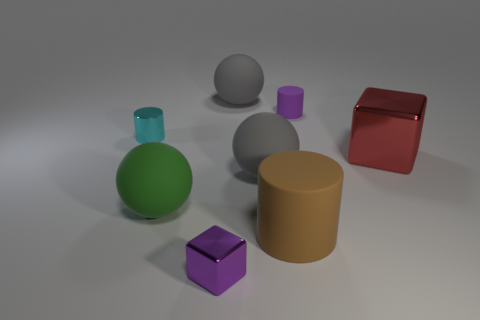Are there any metal objects right of the purple cube?
Provide a short and direct response. Yes. Are there any tiny rubber cylinders left of the cube that is in front of the large brown thing?
Offer a very short reply. No. Is the number of cyan cylinders in front of the brown matte thing the same as the number of gray matte spheres behind the small purple metallic block?
Offer a terse response. No. There is a small thing that is made of the same material as the green ball; what color is it?
Keep it short and to the point. Purple. Is there another cylinder made of the same material as the brown cylinder?
Make the answer very short. Yes. What number of objects are either big green things or large blue objects?
Make the answer very short. 1. Are the big brown object and the purple object that is in front of the small purple rubber cylinder made of the same material?
Provide a short and direct response. No. What is the size of the purple shiny object that is in front of the tiny purple matte cylinder?
Offer a terse response. Small. Are there fewer brown matte cylinders than large gray spheres?
Keep it short and to the point. Yes. Is there a tiny cylinder of the same color as the tiny block?
Ensure brevity in your answer.  Yes. 